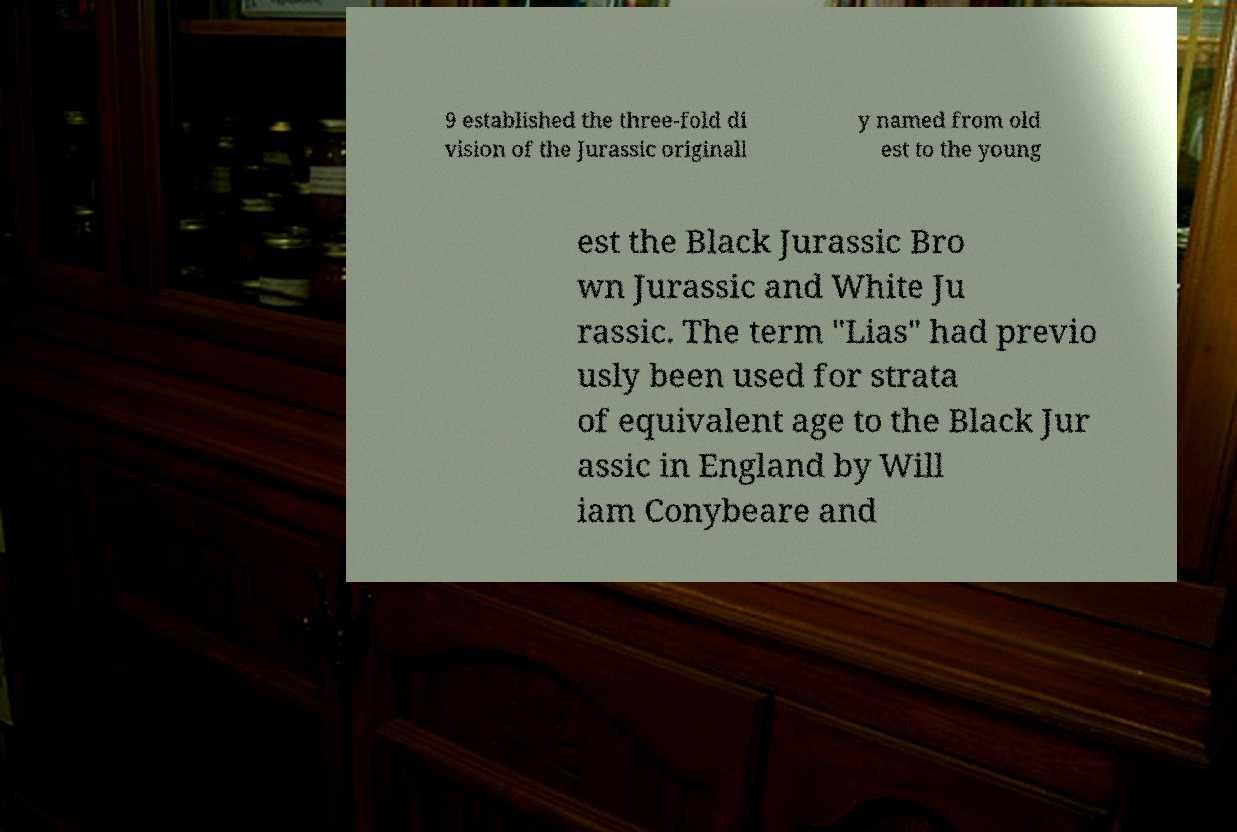There's text embedded in this image that I need extracted. Can you transcribe it verbatim? 9 established the three-fold di vision of the Jurassic originall y named from old est to the young est the Black Jurassic Bro wn Jurassic and White Ju rassic. The term "Lias" had previo usly been used for strata of equivalent age to the Black Jur assic in England by Will iam Conybeare and 